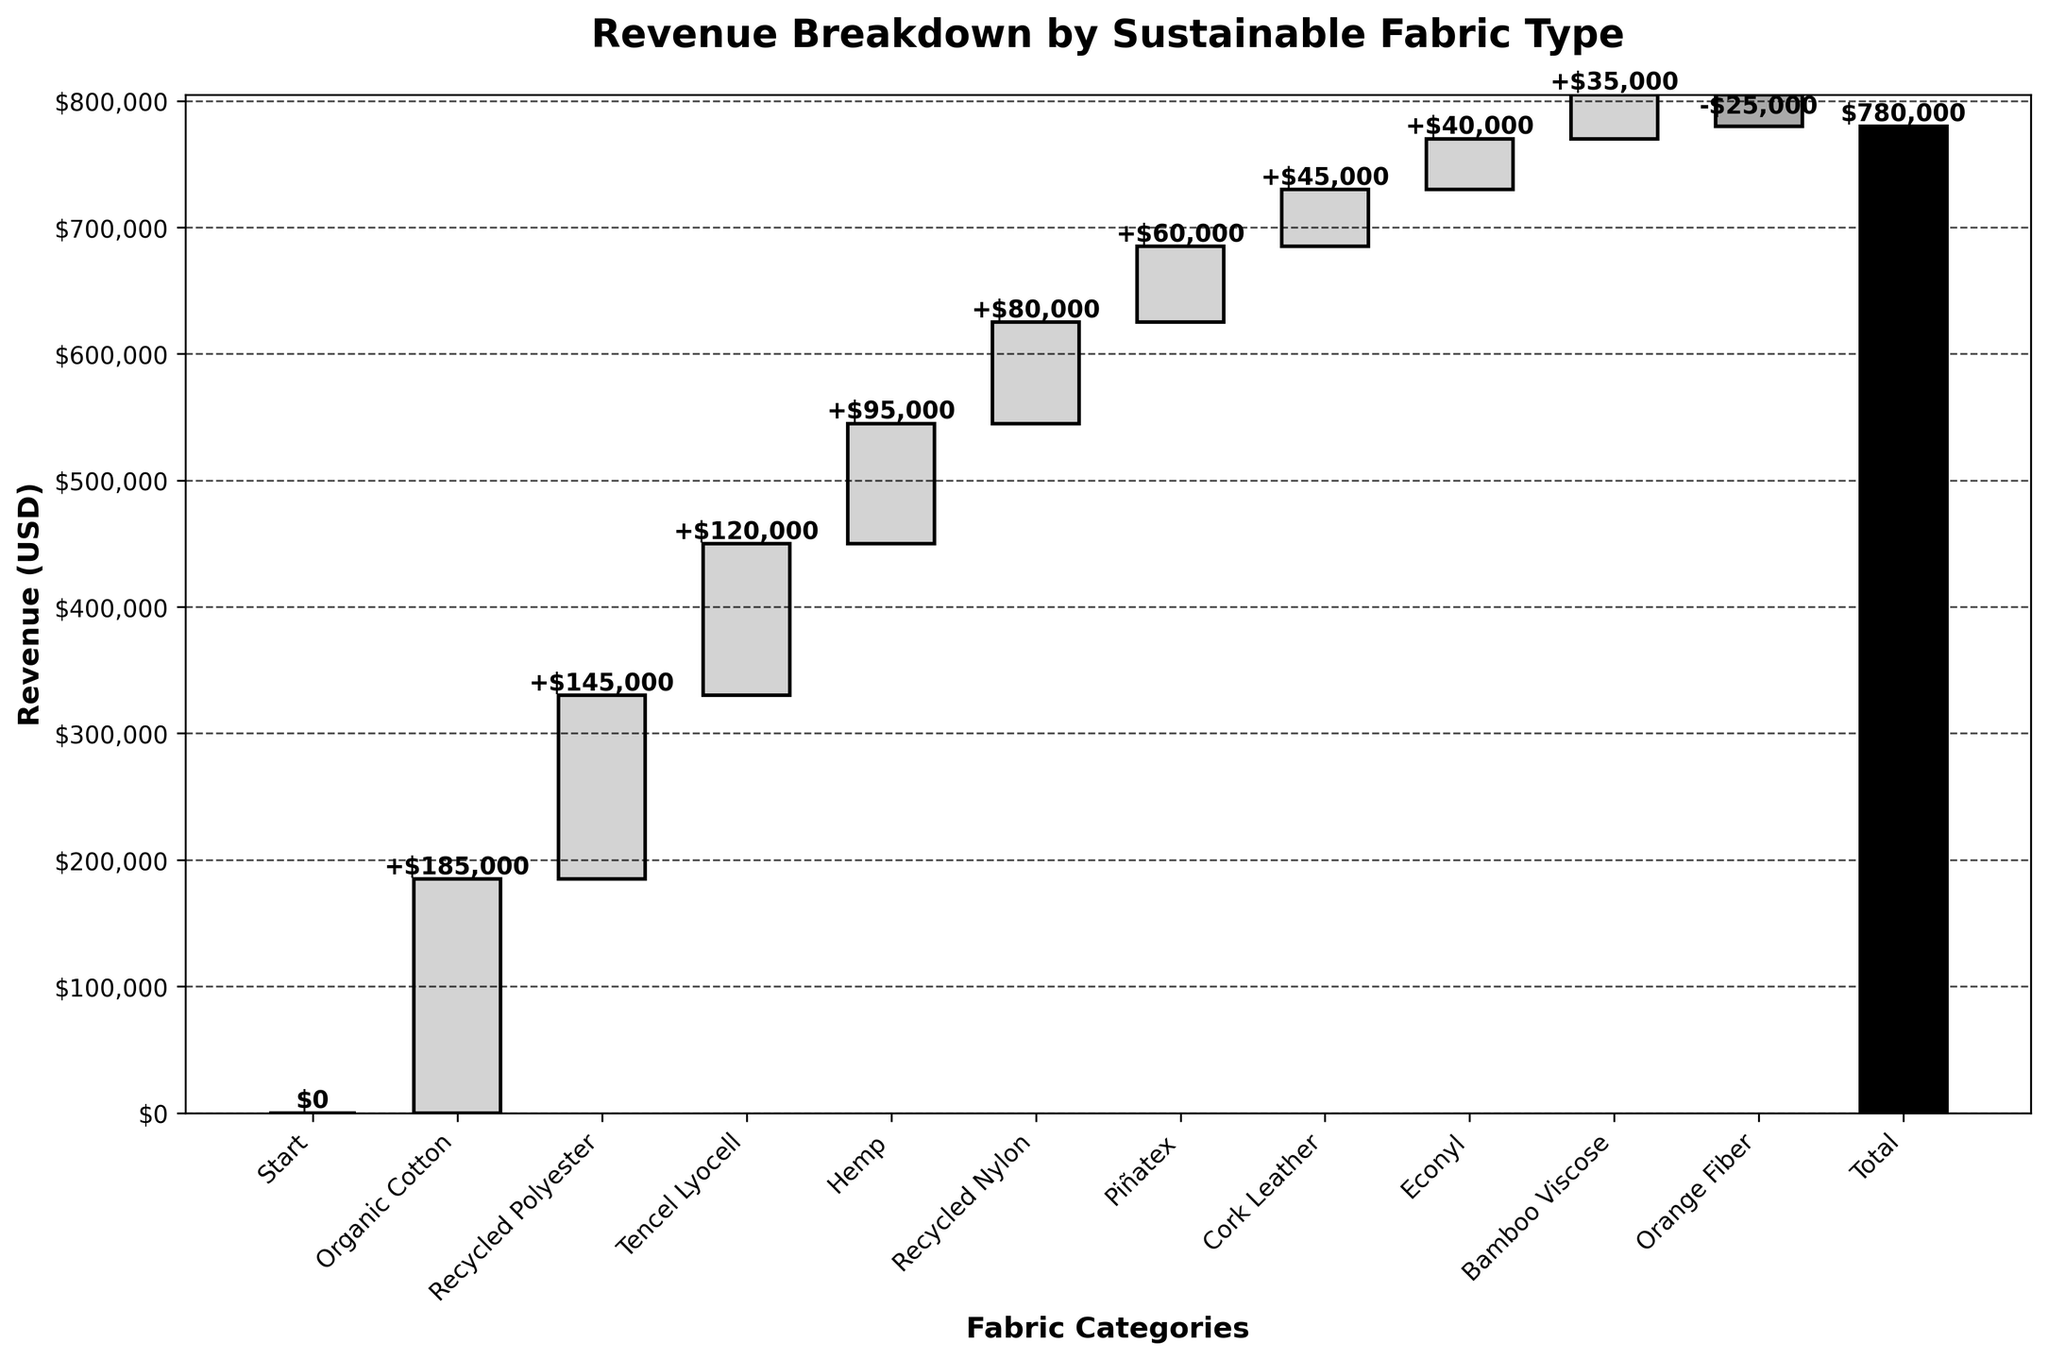what is the title of the chart? The title is found at the top above the bars in bold lettering. It summarizes what the chart represents.
Answer: Revenue Breakdown by Sustainable Fabric Type how many types of sustainable fabrics are listed in the figure? Each bar represents a type of fabric. We count all the categories listed on the x-axis excluding 'Start' and 'Total'.
Answer: 9 which fabric category has the highest revenue? By comparing the heights of the bars, the highest is the one that extends the most upward.
Answer: Organic Cotton by how much does the revenue from Piñatex differ from Hemp? The revenue values for Piñatex and Hemp are $60,000 and $95,000 respectively. The difference is calculated as $95,000 - $60,000.
Answer: $35,000 which fabric category contributed a negative value to the revenue? The negative bar is typically indicated by a label showing a subtraction. Orange Fiber's bar has a negative value.
Answer: Orange Fiber what is the cumulative revenue before adding Bamboo Viscose? Summarize the revenue contributions up to and including Econyl, before Bamboo Viscose. Adding the values $185,000, $145,000, $120,000, $95,000, $80,000, $60,000, $45,000, and $40,000.
Answer: $770,000 which two fabric categories have the smallest revenue difference? Compare the difference in values among all categories to find the smallest. Cork Leather ($45,000) and Econyl ($40,000) have a difference of $5,000.
Answer: Cork Leather and Econyl what’s the overall trend in the revenue contributions by fabric categories? Assess the general flow of the bars, most show positive contributions except for one negative.
Answer: Mostly positive with one negative how is the final revenue value represented in the chart? The final revenue value is the cumulative total of all contributions and is shown as the last bar labeled 'Total'.
Answer: $780,000 